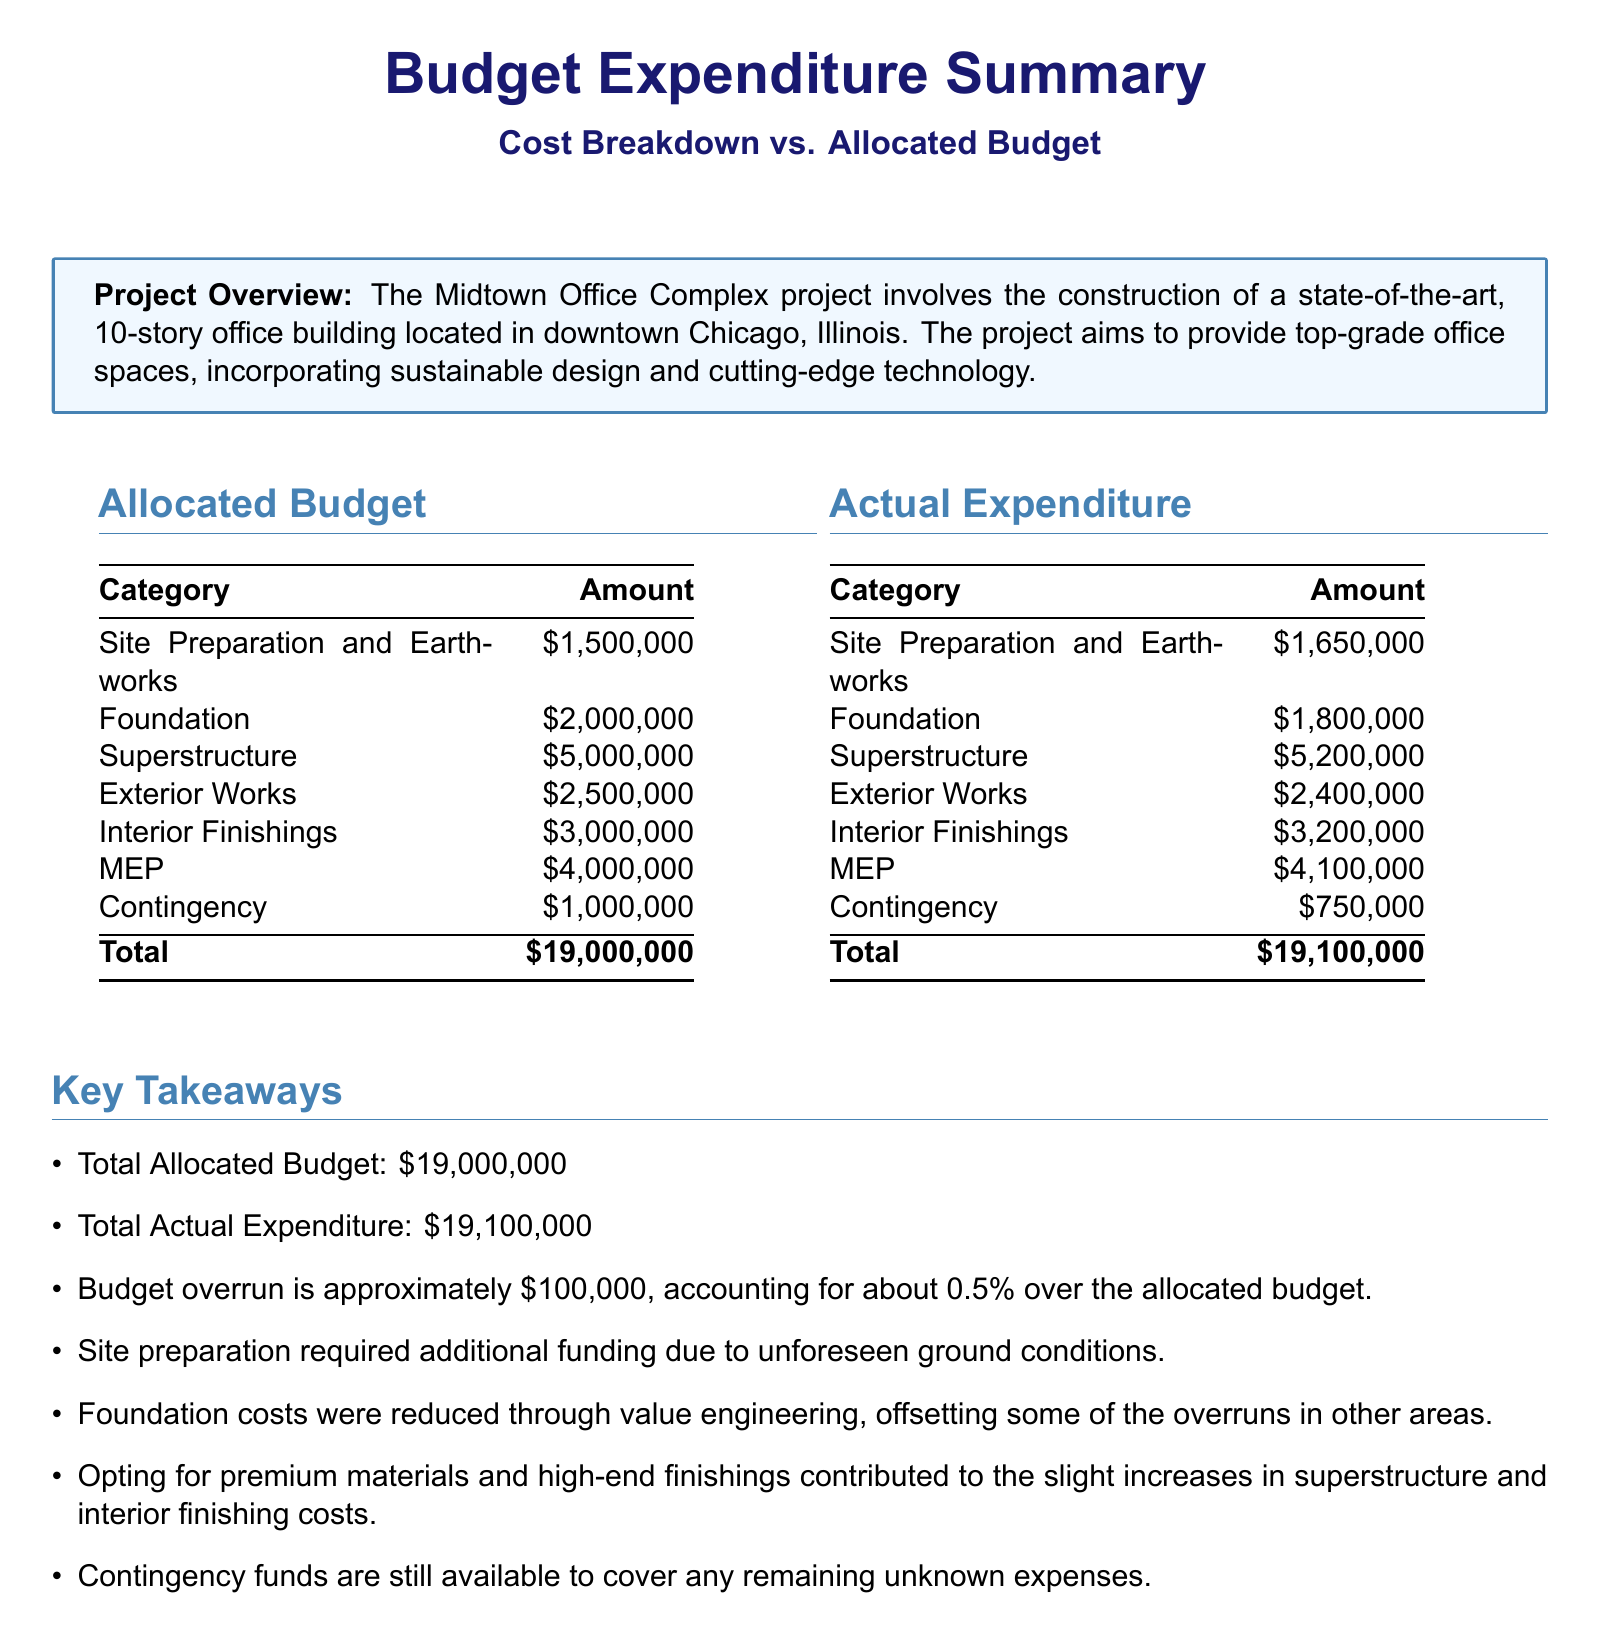What is the total allocated budget? The total allocated budget is explicitly stated in the document, which is $19,000,000.
Answer: $19,000,000 What was the actual expenditure for the Superstructure? The actual expenditure for the Superstructure is provided in the table of Actual Expenditure, which amounts to $5,200,000.
Answer: $5,200,000 How much was spent on the Contingency category? The amount spent on the Contingency category can be found in the Actual Expenditure section, listed as $750,000.
Answer: $750,000 What percentage over the allocated budget does the budget overrun represent? The document states that the budget overrun is approximately 0.5% over the allocated budget.
Answer: 0.5% What contributed to the increase in interior finishing costs? The key takeaway mentions that opting for premium materials and high-end finishings contributed to the increase in interior finishing costs.
Answer: Premium materials and high-end finishings How much did the Foundation costs decrease due to value engineering? The document mentions that Foundation costs were reduced through value engineering, but it does not specify an amount, thus no direct numeric answer can be given directly from the document.
Answer: Not specified How much is still available in contingency funds according to the document? The document indicates that Contingency funds are still available to cover any remaining unknown expenses but does not specify an exact amount.
Answer: Not specified What is the total actual expenditure? The total actual expenditure is clearly stated in the document as $19,100,000.
Answer: $19,100,000 What was the expenditure for Site Preparation and Earthworks? The expenditure for Site Preparation and Earthworks is listed in the Actual Expenditure section, which is $1,650,000.
Answer: $1,650,000 